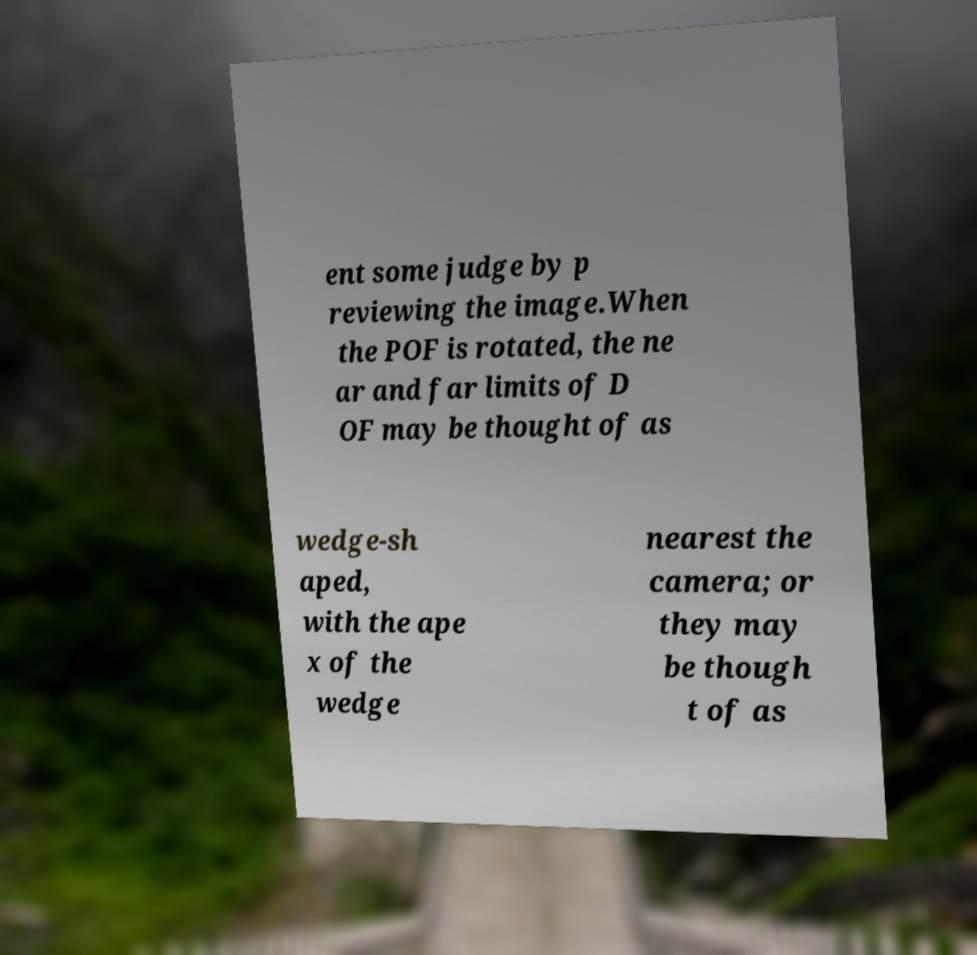There's text embedded in this image that I need extracted. Can you transcribe it verbatim? ent some judge by p reviewing the image.When the POF is rotated, the ne ar and far limits of D OF may be thought of as wedge-sh aped, with the ape x of the wedge nearest the camera; or they may be though t of as 